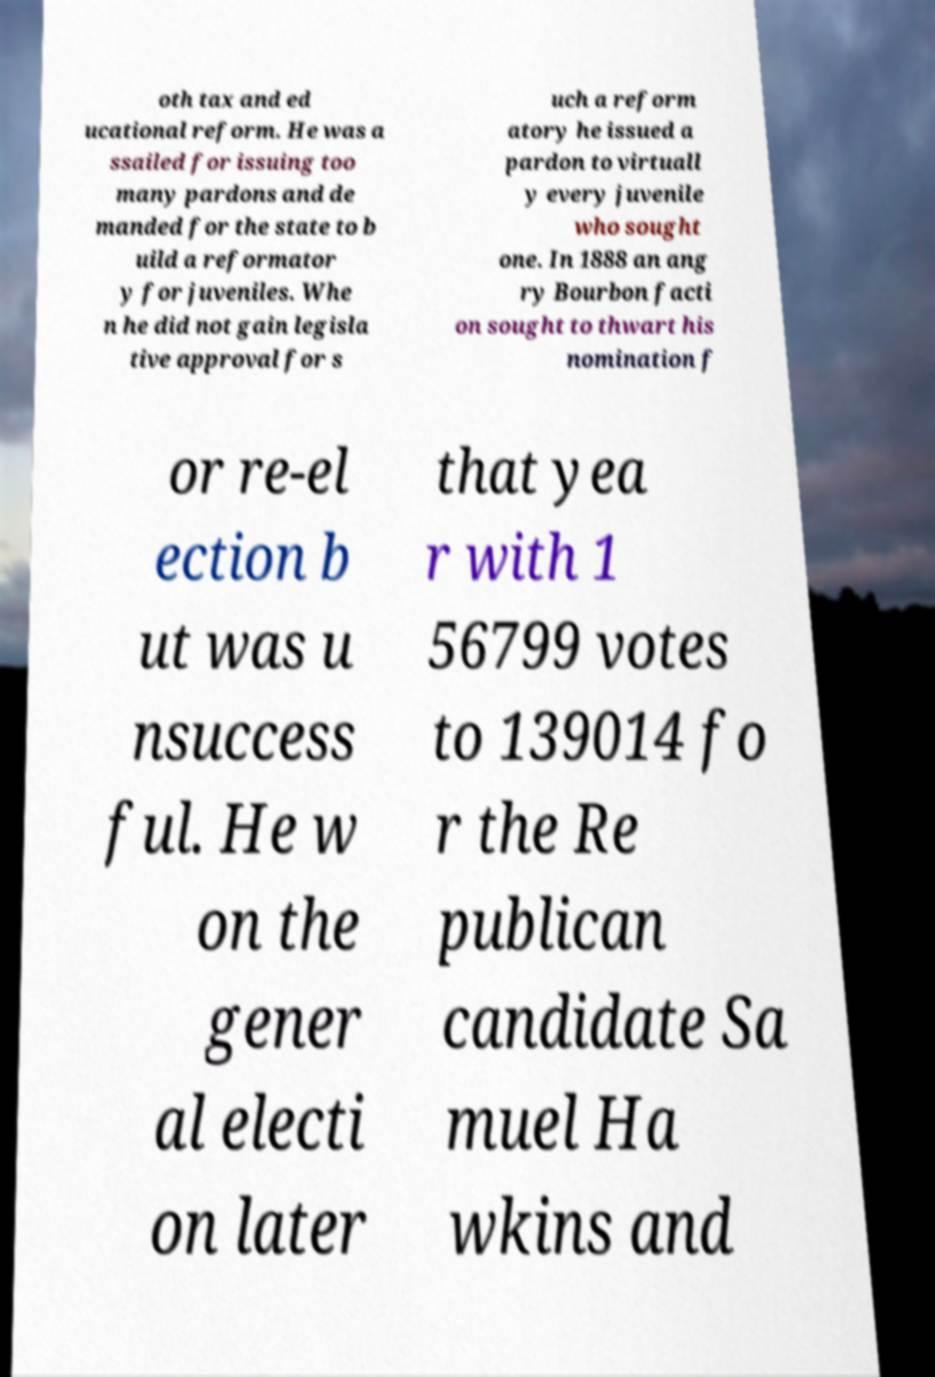There's text embedded in this image that I need extracted. Can you transcribe it verbatim? oth tax and ed ucational reform. He was a ssailed for issuing too many pardons and de manded for the state to b uild a reformator y for juveniles. Whe n he did not gain legisla tive approval for s uch a reform atory he issued a pardon to virtuall y every juvenile who sought one. In 1888 an ang ry Bourbon facti on sought to thwart his nomination f or re-el ection b ut was u nsuccess ful. He w on the gener al electi on later that yea r with 1 56799 votes to 139014 fo r the Re publican candidate Sa muel Ha wkins and 